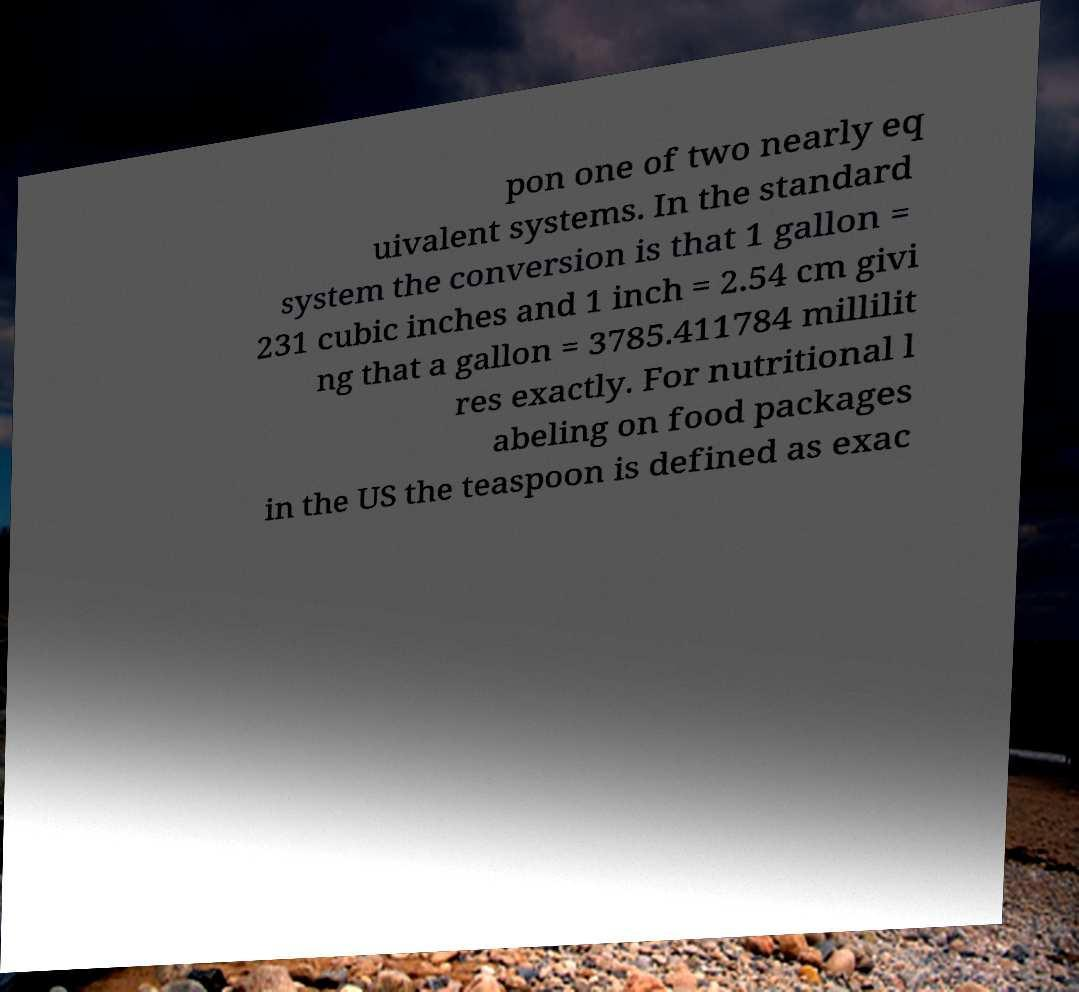Could you assist in decoding the text presented in this image and type it out clearly? pon one of two nearly eq uivalent systems. In the standard system the conversion is that 1 gallon = 231 cubic inches and 1 inch = 2.54 cm givi ng that a gallon = 3785.411784 millilit res exactly. For nutritional l abeling on food packages in the US the teaspoon is defined as exac 